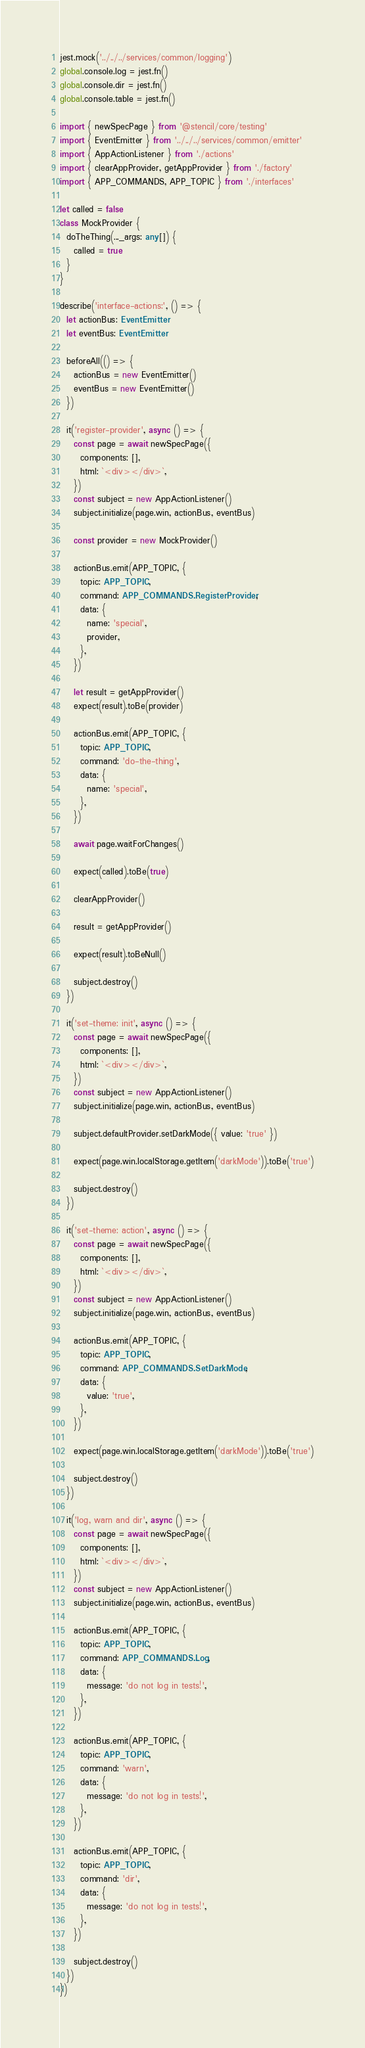<code> <loc_0><loc_0><loc_500><loc_500><_TypeScript_>jest.mock('../../../services/common/logging')
global.console.log = jest.fn()
global.console.dir = jest.fn()
global.console.table = jest.fn()

import { newSpecPage } from '@stencil/core/testing'
import { EventEmitter } from '../../../services/common/emitter'
import { AppActionListener } from './actions'
import { clearAppProvider, getAppProvider } from './factory'
import { APP_COMMANDS, APP_TOPIC } from './interfaces'

let called = false
class MockProvider {
  doTheThing(..._args: any[]) {
    called = true
  }
}

describe('interface-actions:', () => {
  let actionBus: EventEmitter
  let eventBus: EventEmitter

  beforeAll(() => {
    actionBus = new EventEmitter()
    eventBus = new EventEmitter()
  })

  it('register-provider', async () => {
    const page = await newSpecPage({
      components: [],
      html: `<div></div>`,
    })
    const subject = new AppActionListener()
    subject.initialize(page.win, actionBus, eventBus)

    const provider = new MockProvider()

    actionBus.emit(APP_TOPIC, {
      topic: APP_TOPIC,
      command: APP_COMMANDS.RegisterProvider,
      data: {
        name: 'special',
        provider,
      },
    })

    let result = getAppProvider()
    expect(result).toBe(provider)

    actionBus.emit(APP_TOPIC, {
      topic: APP_TOPIC,
      command: 'do-the-thing',
      data: {
        name: 'special',
      },
    })

    await page.waitForChanges()

    expect(called).toBe(true)

    clearAppProvider()

    result = getAppProvider()

    expect(result).toBeNull()

    subject.destroy()
  })

  it('set-theme: init', async () => {
    const page = await newSpecPage({
      components: [],
      html: `<div></div>`,
    })
    const subject = new AppActionListener()
    subject.initialize(page.win, actionBus, eventBus)

    subject.defaultProvider.setDarkMode({ value: 'true' })

    expect(page.win.localStorage.getItem('darkMode')).toBe('true')

    subject.destroy()
  })

  it('set-theme: action', async () => {
    const page = await newSpecPage({
      components: [],
      html: `<div></div>`,
    })
    const subject = new AppActionListener()
    subject.initialize(page.win, actionBus, eventBus)

    actionBus.emit(APP_TOPIC, {
      topic: APP_TOPIC,
      command: APP_COMMANDS.SetDarkMode,
      data: {
        value: 'true',
      },
    })

    expect(page.win.localStorage.getItem('darkMode')).toBe('true')

    subject.destroy()
  })

  it('log, warn and dir', async () => {
    const page = await newSpecPage({
      components: [],
      html: `<div></div>`,
    })
    const subject = new AppActionListener()
    subject.initialize(page.win, actionBus, eventBus)

    actionBus.emit(APP_TOPIC, {
      topic: APP_TOPIC,
      command: APP_COMMANDS.Log,
      data: {
        message: 'do not log in tests!',
      },
    })

    actionBus.emit(APP_TOPIC, {
      topic: APP_TOPIC,
      command: 'warn',
      data: {
        message: 'do not log in tests!',
      },
    })

    actionBus.emit(APP_TOPIC, {
      topic: APP_TOPIC,
      command: 'dir',
      data: {
        message: 'do not log in tests!',
      },
    })

    subject.destroy()
  })
})
</code> 